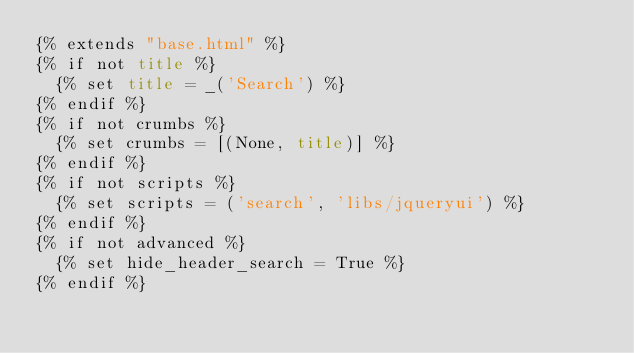<code> <loc_0><loc_0><loc_500><loc_500><_HTML_>{% extends "base.html" %}
{% if not title %}
  {% set title = _('Search') %}
{% endif %}
{% if not crumbs %}
  {% set crumbs = [(None, title)] %}
{% endif %}
{% if not scripts %}
  {% set scripts = ('search', 'libs/jqueryui') %}
{% endif %}
{% if not advanced %}
  {% set hide_header_search = True %}
{% endif %}
</code> 